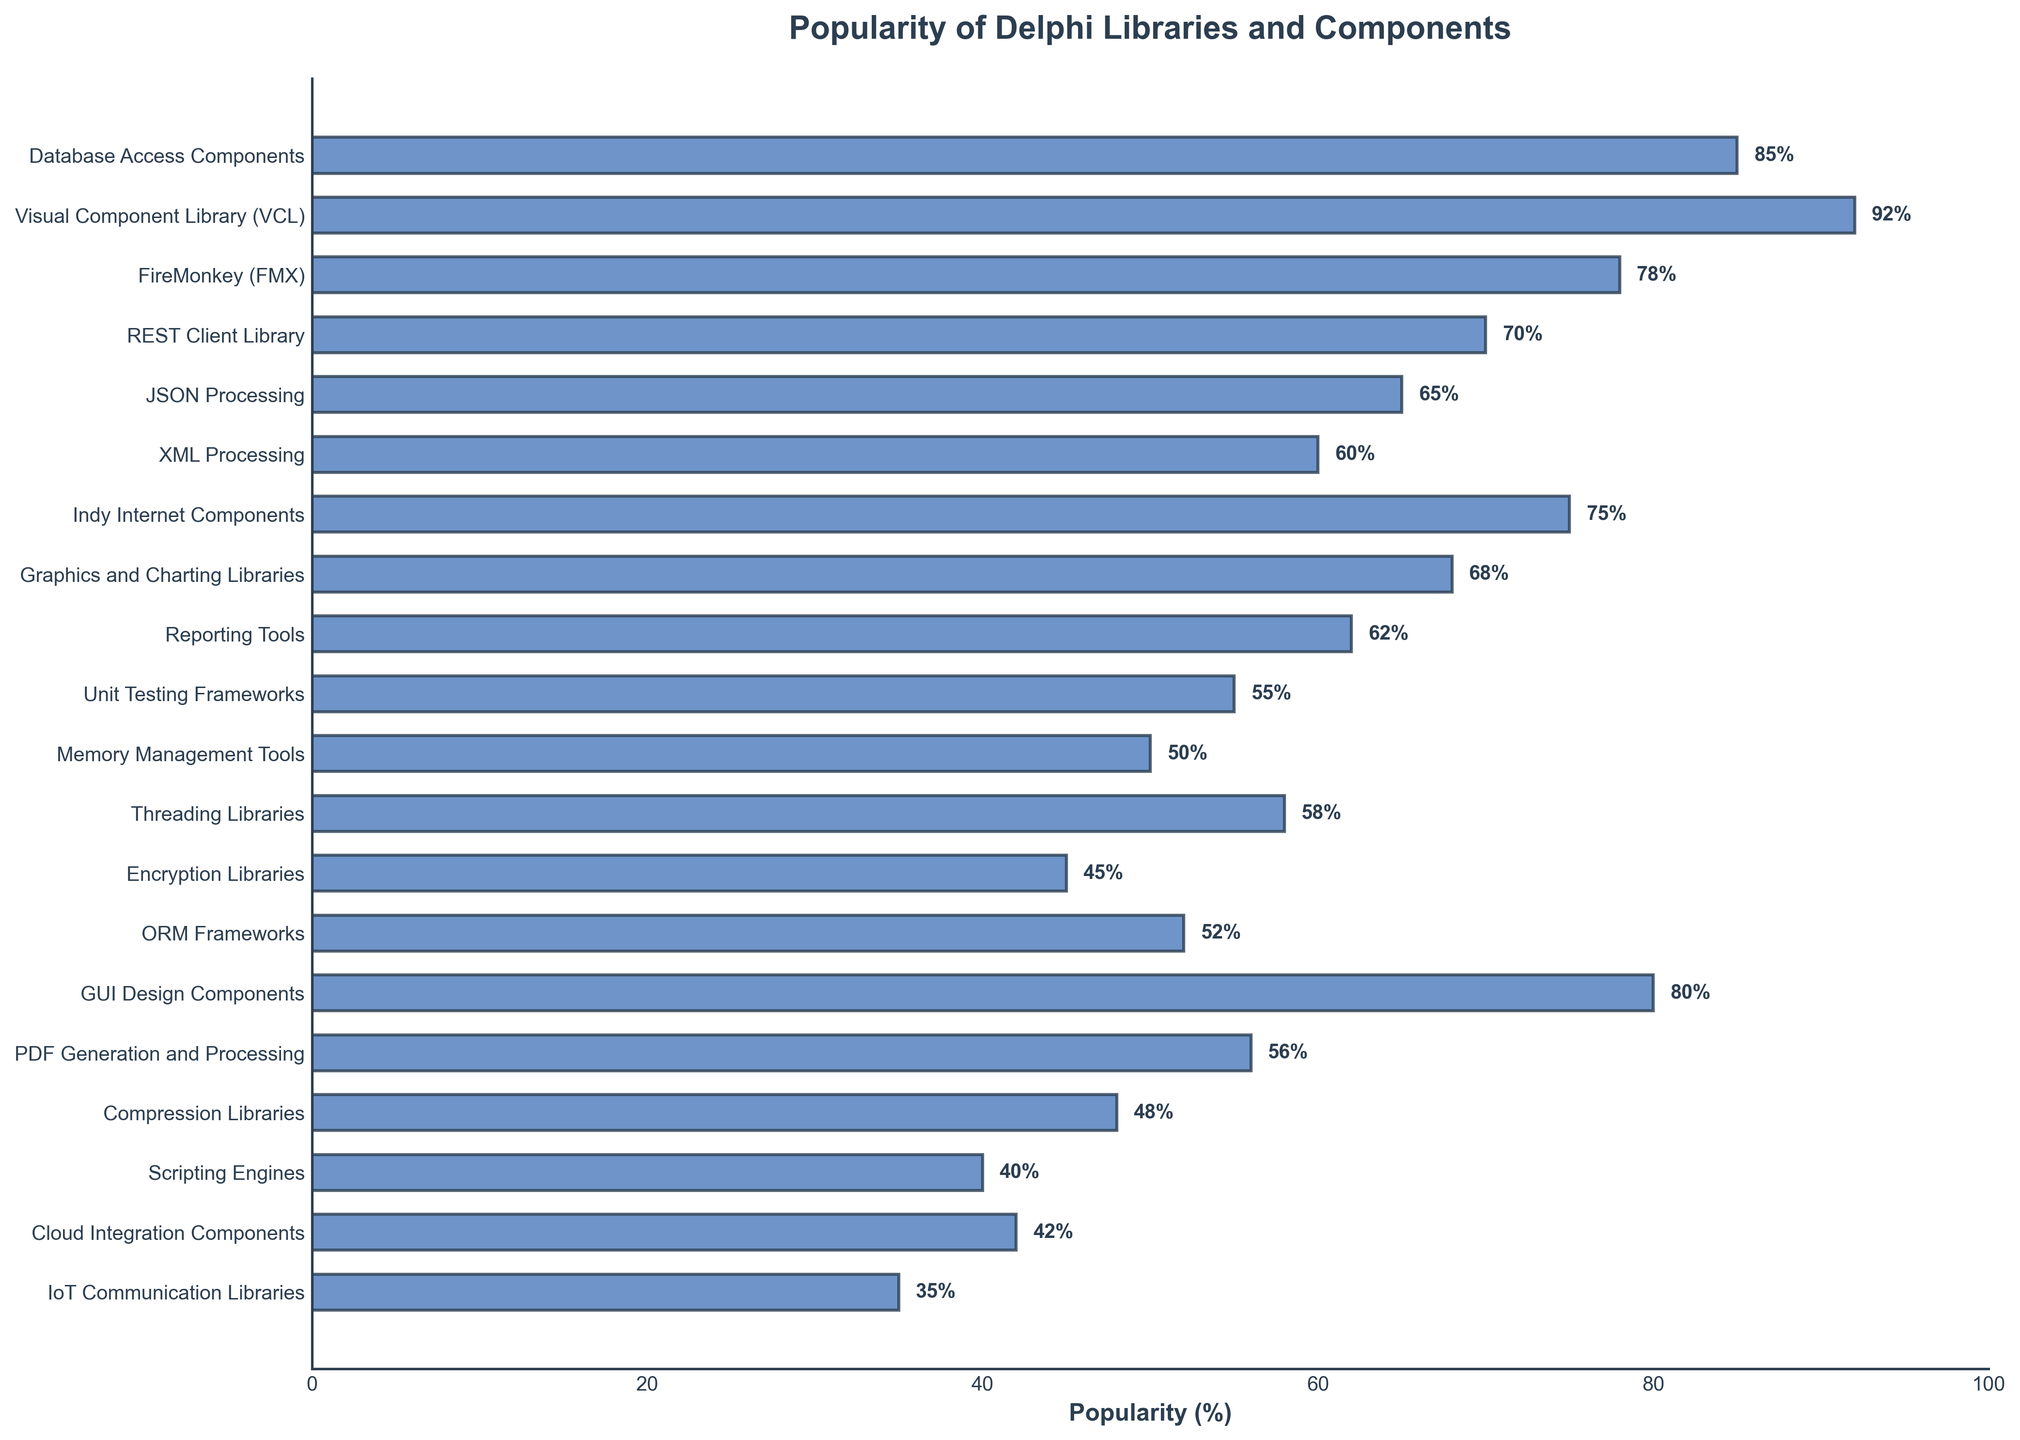Which Delphi library or component category has the highest popularity? To find the category with the highest popularity, examine the bar with the longest length. The Visual Component Library (VCL) has the highest popularity with 92%.
Answer: Visual Component Library (VCL) Which category is more popular, "FireMonkey (FMX)" or "Indy Internet Components"? Compare the lengths of the bars for "FireMonkey (FMX)" and "Indy Internet Components". "FireMonkey (FMX)" has a popularity of 78%, while "Indy Internet Components" has 75%.
Answer: FireMonkey (FMX) What is the difference in popularity between "JSON Processing" and "XML Processing"? Subtract the popularity percentage of "XML Processing" (60%) from that of "JSON Processing" (65%). 65% - 60% = 5%.
Answer: 5% What is the average popularity of "Unit Testing Frameworks", "Memory Management Tools", and "Threading Libraries"? Add the popularity percentages of "Unit Testing Frameworks" (55%), "Memory Management Tools" (50%), and "Threading Libraries" (58%), then divide by 3. (55% + 50% + 58%) / 3 = 54.3%.
Answer: 54.3% Which category has the least popularity? Look for the bar with the shortest length. "IoT Communication Libraries" has the least popularity with 35%.
Answer: IoT Communication Libraries Are "Scripting Engines" and "Cloud Integration Components" equally popular? Compare the lengths of the bars for "Scripting Engines" and "Cloud Integration Components". They have popularity ratings of 40% and 42%, respectively.
Answer: No How many categories have a popularity of 60% or higher? Count the number of bars with a value of 60% or more. There are nine such categories: Database Access Components, Visual Component Library (VCL), FireMonkey (FMX), REST Client Library, JSON Processing, XML Processing, Indy Internet Components, Graphics & Charting Libraries, and Reporting Tools.
Answer: 9 What is the combined popularity of "Compression Libraries" and "PDF Generation and Processing"? Add the popularity percentages of "Compression Libraries" (48%) and "PDF Generation and Processing" (56%). 48% + 56% = 104%.
Answer: 104% What is the difference in popularity between the most popular and the least popular category? Subtract the popularity percentage of the least popular category (IoT Communication Libraries) from that of the most popular (Visual Component Library (VCL)). 92% - 35% = 57%.
Answer: 57% Which category ranks in the middle of popularity amongst all listed categories? List the categories in descending order of popularity and find the middle one. There are 20 categories, and the middle one is the 10th and 11th. The categories are JSON Processing and XML Processing, both fulfilling this criterion when sorted.
Answer: JSON Processing, XML Processing 